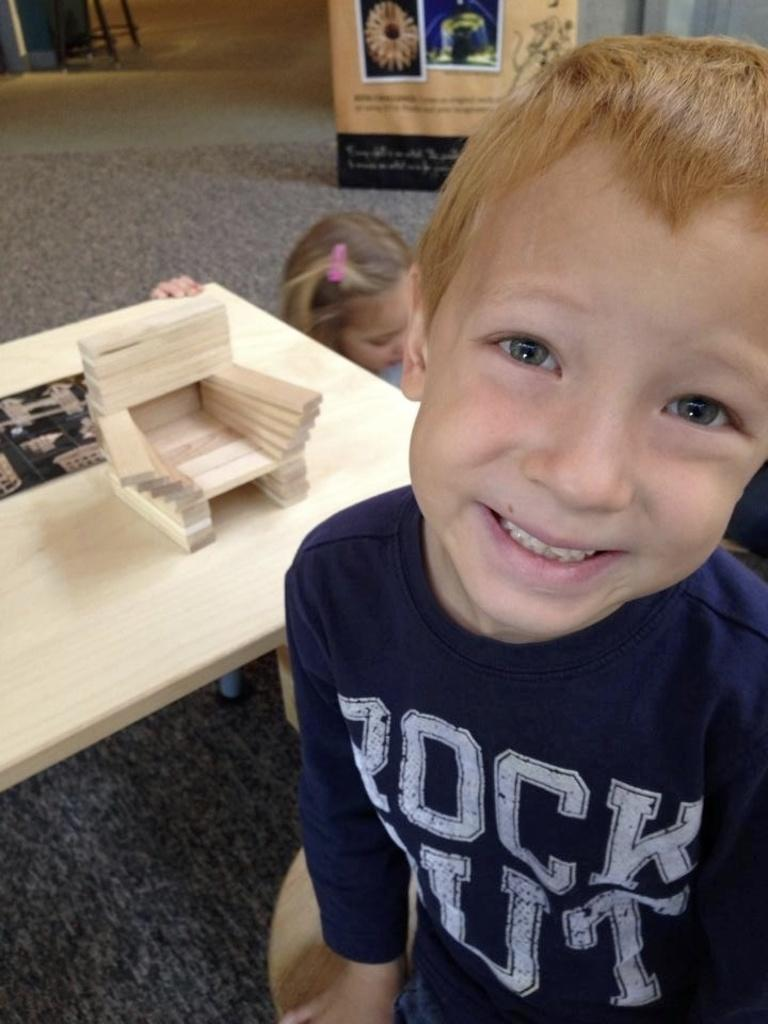What is the kid in the image wearing? The kid is wearing a blue shirt in the image. What is the kid doing in the image? The kid is sitting on a stool. What object is present in the image that the kid might be using? There is a table in the image that the kid might be using. Can you describe the position of the second kid in the image? There is another kid behind the first kid in the image. What type of scene or event is taking place in the image? There is no specific scene or event depicted in the image; it simply shows a kid sitting on a stool with another kid behind them. How does the temper of the kids in the image affect the overall mood of the scene? There is no information about the kids' temper or the overall mood of the scene in the image. 